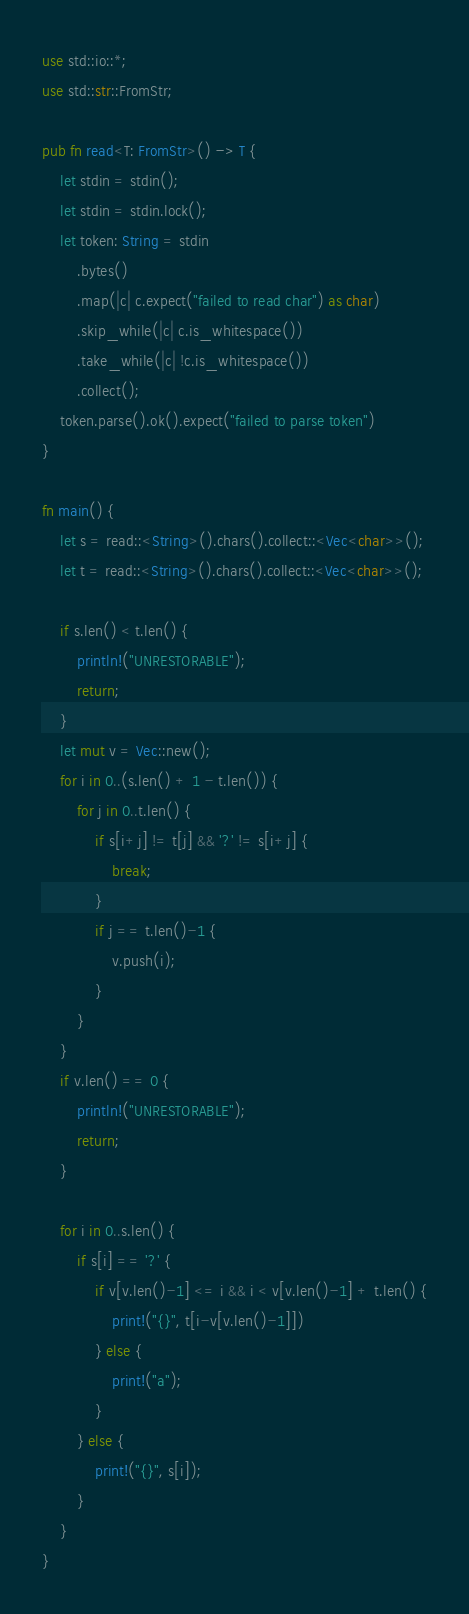<code> <loc_0><loc_0><loc_500><loc_500><_Rust_>use std::io::*;
use std::str::FromStr;

pub fn read<T: FromStr>() -> T {
    let stdin = stdin();
    let stdin = stdin.lock();
    let token: String = stdin
        .bytes()
        .map(|c| c.expect("failed to read char") as char)
        .skip_while(|c| c.is_whitespace())
        .take_while(|c| !c.is_whitespace())
        .collect();
    token.parse().ok().expect("failed to parse token")
}

fn main() {
    let s = read::<String>().chars().collect::<Vec<char>>();
    let t = read::<String>().chars().collect::<Vec<char>>();

    if s.len() < t.len() {
        println!("UNRESTORABLE");
        return;
    }
    let mut v = Vec::new();
    for i in 0..(s.len() + 1 - t.len()) {
        for j in 0..t.len() {
            if s[i+j] != t[j] && '?' != s[i+j] {
                break;
            }
            if j == t.len()-1 {
                v.push(i);
            }
        }
    }
    if v.len() == 0 {
        println!("UNRESTORABLE");
        return;
    }

    for i in 0..s.len() {
        if s[i] == '?' {
            if v[v.len()-1] <= i && i < v[v.len()-1] + t.len() {
                print!("{}", t[i-v[v.len()-1]])
            } else {
                print!("a");
            }
        } else {
            print!("{}", s[i]);
        }
    }
}</code> 